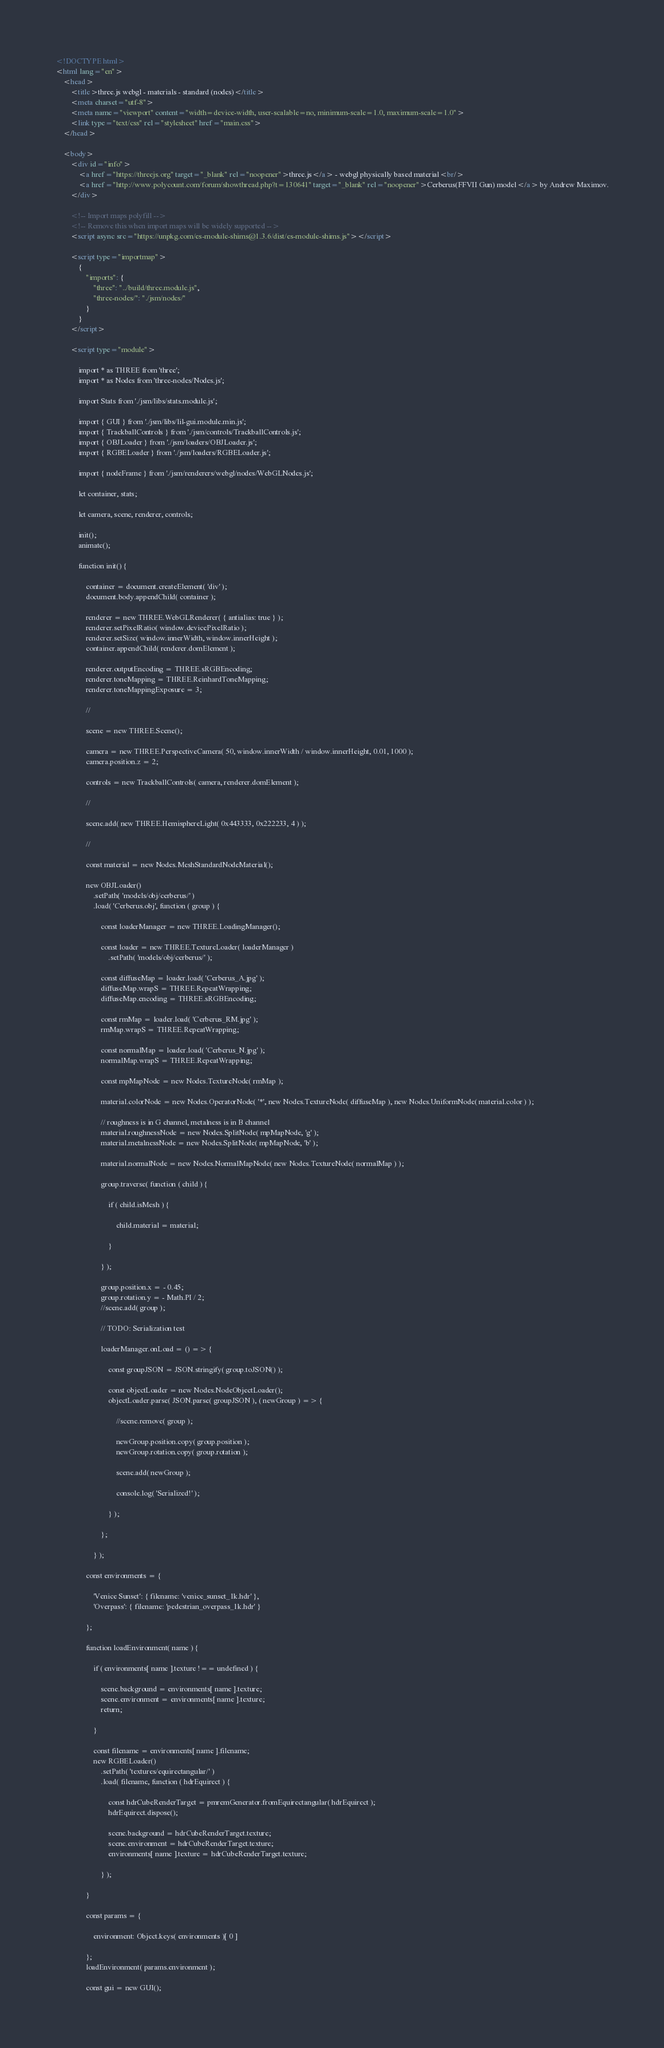<code> <loc_0><loc_0><loc_500><loc_500><_HTML_><!DOCTYPE html>
<html lang="en">
	<head>
		<title>three.js webgl - materials - standard (nodes)</title>
		<meta charset="utf-8">
		<meta name="viewport" content="width=device-width, user-scalable=no, minimum-scale=1.0, maximum-scale=1.0">
		<link type="text/css" rel="stylesheet" href="main.css">
	</head>

	<body>
		<div id="info">
			<a href="https://threejs.org" target="_blank" rel="noopener">three.js</a> - webgl physically based material<br/>
			<a href="http://www.polycount.com/forum/showthread.php?t=130641" target="_blank" rel="noopener">Cerberus(FFVII Gun) model</a> by Andrew Maximov.
		</div>

		<!-- Import maps polyfill -->
		<!-- Remove this when import maps will be widely supported -->
		<script async src="https://unpkg.com/es-module-shims@1.3.6/dist/es-module-shims.js"></script>

		<script type="importmap">
			{
				"imports": {
					"three": "../build/three.module.js",
					"three-nodes/": "./jsm/nodes/"
				}
			}
		</script>

		<script type="module">

			import * as THREE from 'three';
			import * as Nodes from 'three-nodes/Nodes.js';

			import Stats from './jsm/libs/stats.module.js';

			import { GUI } from './jsm/libs/lil-gui.module.min.js';
			import { TrackballControls } from './jsm/controls/TrackballControls.js';
			import { OBJLoader } from './jsm/loaders/OBJLoader.js';
			import { RGBELoader } from './jsm/loaders/RGBELoader.js';

			import { nodeFrame } from './jsm/renderers/webgl/nodes/WebGLNodes.js';

			let container, stats;

			let camera, scene, renderer, controls;

			init();
			animate();

			function init() {

				container = document.createElement( 'div' );
				document.body.appendChild( container );

				renderer = new THREE.WebGLRenderer( { antialias: true } );
				renderer.setPixelRatio( window.devicePixelRatio );
				renderer.setSize( window.innerWidth, window.innerHeight );
				container.appendChild( renderer.domElement );

				renderer.outputEncoding = THREE.sRGBEncoding;
				renderer.toneMapping = THREE.ReinhardToneMapping;
				renderer.toneMappingExposure = 3;

				//

				scene = new THREE.Scene();

				camera = new THREE.PerspectiveCamera( 50, window.innerWidth / window.innerHeight, 0.01, 1000 );
				camera.position.z = 2;

				controls = new TrackballControls( camera, renderer.domElement );

				//

				scene.add( new THREE.HemisphereLight( 0x443333, 0x222233, 4 ) );

				//

				const material = new Nodes.MeshStandardNodeMaterial();

				new OBJLoader()
					.setPath( 'models/obj/cerberus/' )
					.load( 'Cerberus.obj', function ( group ) {

						const loaderManager = new THREE.LoadingManager();

						const loader = new THREE.TextureLoader( loaderManager )
							.setPath( 'models/obj/cerberus/' );

						const diffuseMap = loader.load( 'Cerberus_A.jpg' );
						diffuseMap.wrapS = THREE.RepeatWrapping;
						diffuseMap.encoding = THREE.sRGBEncoding;

						const rmMap = loader.load( 'Cerberus_RM.jpg' );
						rmMap.wrapS = THREE.RepeatWrapping;

						const normalMap = loader.load( 'Cerberus_N.jpg' );
						normalMap.wrapS = THREE.RepeatWrapping;

						const mpMapNode = new Nodes.TextureNode( rmMap );

						material.colorNode = new Nodes.OperatorNode( '*', new Nodes.TextureNode( diffuseMap ), new Nodes.UniformNode( material.color ) );

						// roughness is in G channel, metalness is in B channel
						material.roughnessNode = new Nodes.SplitNode( mpMapNode, 'g' );
						material.metalnessNode = new Nodes.SplitNode( mpMapNode, 'b' );

						material.normalNode = new Nodes.NormalMapNode( new Nodes.TextureNode( normalMap ) );

						group.traverse( function ( child ) {

							if ( child.isMesh ) {

								child.material = material;

							}

						} );

						group.position.x = - 0.45;
						group.rotation.y = - Math.PI / 2;
						//scene.add( group );

						// TODO: Serialization test

						loaderManager.onLoad = () => {

							const groupJSON = JSON.stringify( group.toJSON() );

							const objectLoader = new Nodes.NodeObjectLoader();
							objectLoader.parse( JSON.parse( groupJSON ), ( newGroup ) => {

								//scene.remove( group );

								newGroup.position.copy( group.position );
								newGroup.rotation.copy( group.rotation );

								scene.add( newGroup );

								console.log( 'Serialized!' );

							} );

						};

					} );

				const environments = {

					'Venice Sunset': { filename: 'venice_sunset_1k.hdr' },
					'Overpass': { filename: 'pedestrian_overpass_1k.hdr' }

				};

				function loadEnvironment( name ) {

					if ( environments[ name ].texture !== undefined ) {

						scene.background = environments[ name ].texture;
						scene.environment = environments[ name ].texture;
						return;

					}

					const filename = environments[ name ].filename;
					new RGBELoader()
						.setPath( 'textures/equirectangular/' )
						.load( filename, function ( hdrEquirect ) {

							const hdrCubeRenderTarget = pmremGenerator.fromEquirectangular( hdrEquirect );
							hdrEquirect.dispose();

							scene.background = hdrCubeRenderTarget.texture;
							scene.environment = hdrCubeRenderTarget.texture;
							environments[ name ].texture = hdrCubeRenderTarget.texture;

						} );

				}

				const params = {

					environment: Object.keys( environments )[ 0 ]

				};
				loadEnvironment( params.environment );

				const gui = new GUI();</code> 